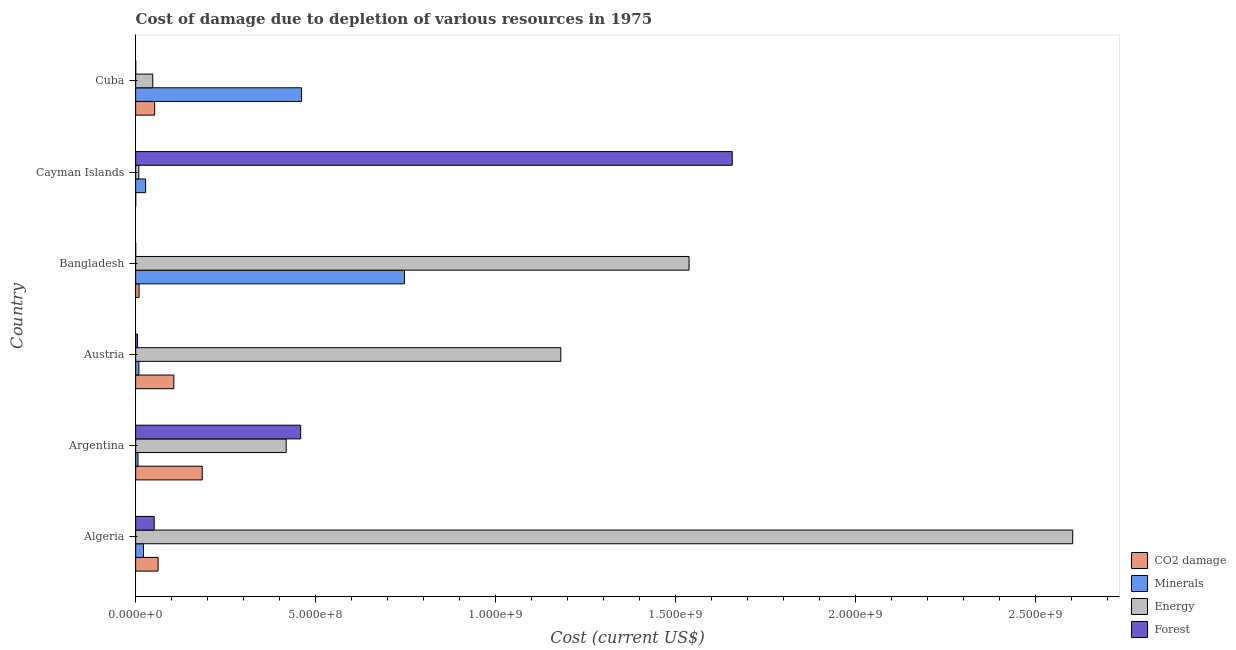How many different coloured bars are there?
Your answer should be very brief. 4. How many bars are there on the 5th tick from the top?
Provide a short and direct response. 4. What is the cost of damage due to depletion of forests in Argentina?
Your answer should be very brief. 4.58e+08. Across all countries, what is the maximum cost of damage due to depletion of energy?
Your answer should be compact. 2.60e+09. Across all countries, what is the minimum cost of damage due to depletion of forests?
Ensure brevity in your answer.  8.47e+04. What is the total cost of damage due to depletion of energy in the graph?
Make the answer very short. 5.80e+09. What is the difference between the cost of damage due to depletion of forests in Argentina and that in Austria?
Keep it short and to the point. 4.53e+08. What is the difference between the cost of damage due to depletion of coal in Austria and the cost of damage due to depletion of forests in Algeria?
Your response must be concise. 5.45e+07. What is the average cost of damage due to depletion of energy per country?
Provide a short and direct response. 9.66e+08. What is the difference between the cost of damage due to depletion of minerals and cost of damage due to depletion of forests in Cuba?
Offer a very short reply. 4.61e+08. In how many countries, is the cost of damage due to depletion of coal greater than 1400000000 US$?
Make the answer very short. 0. What is the ratio of the cost of damage due to depletion of minerals in Argentina to that in Austria?
Ensure brevity in your answer.  0.72. Is the cost of damage due to depletion of coal in Algeria less than that in Cayman Islands?
Your answer should be very brief. No. Is the difference between the cost of damage due to depletion of minerals in Algeria and Cuba greater than the difference between the cost of damage due to depletion of forests in Algeria and Cuba?
Make the answer very short. No. What is the difference between the highest and the second highest cost of damage due to depletion of forests?
Your answer should be very brief. 1.20e+09. What is the difference between the highest and the lowest cost of damage due to depletion of minerals?
Keep it short and to the point. 7.40e+08. In how many countries, is the cost of damage due to depletion of minerals greater than the average cost of damage due to depletion of minerals taken over all countries?
Keep it short and to the point. 2. Is it the case that in every country, the sum of the cost of damage due to depletion of energy and cost of damage due to depletion of minerals is greater than the sum of cost of damage due to depletion of coal and cost of damage due to depletion of forests?
Offer a very short reply. No. What does the 2nd bar from the top in Algeria represents?
Provide a succinct answer. Energy. What does the 2nd bar from the bottom in Cayman Islands represents?
Offer a very short reply. Minerals. Is it the case that in every country, the sum of the cost of damage due to depletion of coal and cost of damage due to depletion of minerals is greater than the cost of damage due to depletion of energy?
Offer a very short reply. No. What is the difference between two consecutive major ticks on the X-axis?
Provide a short and direct response. 5.00e+08. Does the graph contain any zero values?
Offer a very short reply. No. Does the graph contain grids?
Provide a short and direct response. No. How many legend labels are there?
Give a very brief answer. 4. What is the title of the graph?
Offer a very short reply. Cost of damage due to depletion of various resources in 1975 . What is the label or title of the X-axis?
Offer a very short reply. Cost (current US$). What is the label or title of the Y-axis?
Make the answer very short. Country. What is the Cost (current US$) in CO2 damage in Algeria?
Ensure brevity in your answer.  6.24e+07. What is the Cost (current US$) of Minerals in Algeria?
Offer a very short reply. 2.17e+07. What is the Cost (current US$) of Energy in Algeria?
Give a very brief answer. 2.60e+09. What is the Cost (current US$) in Forest in Algeria?
Offer a very short reply. 5.14e+07. What is the Cost (current US$) of CO2 damage in Argentina?
Keep it short and to the point. 1.85e+08. What is the Cost (current US$) of Minerals in Argentina?
Your answer should be compact. 6.41e+06. What is the Cost (current US$) in Energy in Argentina?
Offer a very short reply. 4.18e+08. What is the Cost (current US$) of Forest in Argentina?
Provide a short and direct response. 4.58e+08. What is the Cost (current US$) of CO2 damage in Austria?
Keep it short and to the point. 1.06e+08. What is the Cost (current US$) of Minerals in Austria?
Ensure brevity in your answer.  8.94e+06. What is the Cost (current US$) in Energy in Austria?
Provide a short and direct response. 1.18e+09. What is the Cost (current US$) in Forest in Austria?
Your answer should be very brief. 5.10e+06. What is the Cost (current US$) of CO2 damage in Bangladesh?
Give a very brief answer. 9.49e+06. What is the Cost (current US$) in Minerals in Bangladesh?
Provide a succinct answer. 7.47e+08. What is the Cost (current US$) in Energy in Bangladesh?
Ensure brevity in your answer.  1.54e+09. What is the Cost (current US$) of Forest in Bangladesh?
Provide a succinct answer. 8.47e+04. What is the Cost (current US$) of CO2 damage in Cayman Islands?
Ensure brevity in your answer.  1.14e+05. What is the Cost (current US$) of Minerals in Cayman Islands?
Ensure brevity in your answer.  2.76e+07. What is the Cost (current US$) in Energy in Cayman Islands?
Make the answer very short. 8.74e+06. What is the Cost (current US$) in Forest in Cayman Islands?
Your answer should be very brief. 1.66e+09. What is the Cost (current US$) of CO2 damage in Cuba?
Your answer should be compact. 5.27e+07. What is the Cost (current US$) of Minerals in Cuba?
Your answer should be compact. 4.61e+08. What is the Cost (current US$) in Energy in Cuba?
Your answer should be compact. 4.74e+07. What is the Cost (current US$) in Forest in Cuba?
Give a very brief answer. 1.50e+05. Across all countries, what is the maximum Cost (current US$) of CO2 damage?
Offer a terse response. 1.85e+08. Across all countries, what is the maximum Cost (current US$) of Minerals?
Provide a succinct answer. 7.47e+08. Across all countries, what is the maximum Cost (current US$) in Energy?
Offer a very short reply. 2.60e+09. Across all countries, what is the maximum Cost (current US$) of Forest?
Make the answer very short. 1.66e+09. Across all countries, what is the minimum Cost (current US$) of CO2 damage?
Provide a short and direct response. 1.14e+05. Across all countries, what is the minimum Cost (current US$) in Minerals?
Provide a short and direct response. 6.41e+06. Across all countries, what is the minimum Cost (current US$) in Energy?
Offer a very short reply. 8.74e+06. Across all countries, what is the minimum Cost (current US$) of Forest?
Provide a succinct answer. 8.47e+04. What is the total Cost (current US$) in CO2 damage in the graph?
Your answer should be compact. 4.16e+08. What is the total Cost (current US$) in Minerals in the graph?
Provide a succinct answer. 1.27e+09. What is the total Cost (current US$) in Energy in the graph?
Offer a very short reply. 5.80e+09. What is the total Cost (current US$) of Forest in the graph?
Give a very brief answer. 2.17e+09. What is the difference between the Cost (current US$) in CO2 damage in Algeria and that in Argentina?
Give a very brief answer. -1.23e+08. What is the difference between the Cost (current US$) in Minerals in Algeria and that in Argentina?
Ensure brevity in your answer.  1.53e+07. What is the difference between the Cost (current US$) of Energy in Algeria and that in Argentina?
Make the answer very short. 2.18e+09. What is the difference between the Cost (current US$) in Forest in Algeria and that in Argentina?
Offer a terse response. -4.07e+08. What is the difference between the Cost (current US$) of CO2 damage in Algeria and that in Austria?
Offer a terse response. -4.36e+07. What is the difference between the Cost (current US$) in Minerals in Algeria and that in Austria?
Offer a very short reply. 1.27e+07. What is the difference between the Cost (current US$) of Energy in Algeria and that in Austria?
Provide a succinct answer. 1.42e+09. What is the difference between the Cost (current US$) of Forest in Algeria and that in Austria?
Provide a short and direct response. 4.63e+07. What is the difference between the Cost (current US$) in CO2 damage in Algeria and that in Bangladesh?
Offer a very short reply. 5.29e+07. What is the difference between the Cost (current US$) of Minerals in Algeria and that in Bangladesh?
Make the answer very short. -7.25e+08. What is the difference between the Cost (current US$) in Energy in Algeria and that in Bangladesh?
Provide a short and direct response. 1.07e+09. What is the difference between the Cost (current US$) in Forest in Algeria and that in Bangladesh?
Your answer should be very brief. 5.13e+07. What is the difference between the Cost (current US$) of CO2 damage in Algeria and that in Cayman Islands?
Keep it short and to the point. 6.23e+07. What is the difference between the Cost (current US$) of Minerals in Algeria and that in Cayman Islands?
Your answer should be compact. -5.88e+06. What is the difference between the Cost (current US$) of Energy in Algeria and that in Cayman Islands?
Your response must be concise. 2.59e+09. What is the difference between the Cost (current US$) in Forest in Algeria and that in Cayman Islands?
Make the answer very short. -1.61e+09. What is the difference between the Cost (current US$) of CO2 damage in Algeria and that in Cuba?
Offer a terse response. 9.67e+06. What is the difference between the Cost (current US$) of Minerals in Algeria and that in Cuba?
Provide a short and direct response. -4.39e+08. What is the difference between the Cost (current US$) of Energy in Algeria and that in Cuba?
Your answer should be very brief. 2.56e+09. What is the difference between the Cost (current US$) of Forest in Algeria and that in Cuba?
Offer a very short reply. 5.13e+07. What is the difference between the Cost (current US$) in CO2 damage in Argentina and that in Austria?
Offer a very short reply. 7.90e+07. What is the difference between the Cost (current US$) in Minerals in Argentina and that in Austria?
Your response must be concise. -2.52e+06. What is the difference between the Cost (current US$) of Energy in Argentina and that in Austria?
Make the answer very short. -7.63e+08. What is the difference between the Cost (current US$) in Forest in Argentina and that in Austria?
Give a very brief answer. 4.53e+08. What is the difference between the Cost (current US$) of CO2 damage in Argentina and that in Bangladesh?
Offer a very short reply. 1.75e+08. What is the difference between the Cost (current US$) of Minerals in Argentina and that in Bangladesh?
Offer a terse response. -7.40e+08. What is the difference between the Cost (current US$) of Energy in Argentina and that in Bangladesh?
Ensure brevity in your answer.  -1.12e+09. What is the difference between the Cost (current US$) of Forest in Argentina and that in Bangladesh?
Offer a terse response. 4.58e+08. What is the difference between the Cost (current US$) in CO2 damage in Argentina and that in Cayman Islands?
Give a very brief answer. 1.85e+08. What is the difference between the Cost (current US$) in Minerals in Argentina and that in Cayman Islands?
Offer a terse response. -2.12e+07. What is the difference between the Cost (current US$) in Energy in Argentina and that in Cayman Islands?
Provide a succinct answer. 4.09e+08. What is the difference between the Cost (current US$) in Forest in Argentina and that in Cayman Islands?
Keep it short and to the point. -1.20e+09. What is the difference between the Cost (current US$) of CO2 damage in Argentina and that in Cuba?
Your response must be concise. 1.32e+08. What is the difference between the Cost (current US$) of Minerals in Argentina and that in Cuba?
Keep it short and to the point. -4.54e+08. What is the difference between the Cost (current US$) in Energy in Argentina and that in Cuba?
Your response must be concise. 3.71e+08. What is the difference between the Cost (current US$) of Forest in Argentina and that in Cuba?
Provide a short and direct response. 4.58e+08. What is the difference between the Cost (current US$) in CO2 damage in Austria and that in Bangladesh?
Offer a terse response. 9.65e+07. What is the difference between the Cost (current US$) in Minerals in Austria and that in Bangladesh?
Provide a succinct answer. -7.38e+08. What is the difference between the Cost (current US$) of Energy in Austria and that in Bangladesh?
Your answer should be very brief. -3.56e+08. What is the difference between the Cost (current US$) in Forest in Austria and that in Bangladesh?
Provide a succinct answer. 5.01e+06. What is the difference between the Cost (current US$) of CO2 damage in Austria and that in Cayman Islands?
Your answer should be very brief. 1.06e+08. What is the difference between the Cost (current US$) in Minerals in Austria and that in Cayman Islands?
Provide a short and direct response. -1.86e+07. What is the difference between the Cost (current US$) in Energy in Austria and that in Cayman Islands?
Make the answer very short. 1.17e+09. What is the difference between the Cost (current US$) of Forest in Austria and that in Cayman Islands?
Your answer should be compact. -1.65e+09. What is the difference between the Cost (current US$) of CO2 damage in Austria and that in Cuba?
Your answer should be very brief. 5.32e+07. What is the difference between the Cost (current US$) in Minerals in Austria and that in Cuba?
Offer a very short reply. -4.52e+08. What is the difference between the Cost (current US$) of Energy in Austria and that in Cuba?
Offer a terse response. 1.13e+09. What is the difference between the Cost (current US$) in Forest in Austria and that in Cuba?
Your answer should be compact. 4.95e+06. What is the difference between the Cost (current US$) of CO2 damage in Bangladesh and that in Cayman Islands?
Give a very brief answer. 9.37e+06. What is the difference between the Cost (current US$) of Minerals in Bangladesh and that in Cayman Islands?
Provide a succinct answer. 7.19e+08. What is the difference between the Cost (current US$) in Energy in Bangladesh and that in Cayman Islands?
Provide a succinct answer. 1.53e+09. What is the difference between the Cost (current US$) in Forest in Bangladesh and that in Cayman Islands?
Your answer should be compact. -1.66e+09. What is the difference between the Cost (current US$) of CO2 damage in Bangladesh and that in Cuba?
Provide a succinct answer. -4.32e+07. What is the difference between the Cost (current US$) of Minerals in Bangladesh and that in Cuba?
Offer a terse response. 2.86e+08. What is the difference between the Cost (current US$) in Energy in Bangladesh and that in Cuba?
Make the answer very short. 1.49e+09. What is the difference between the Cost (current US$) in Forest in Bangladesh and that in Cuba?
Keep it short and to the point. -6.53e+04. What is the difference between the Cost (current US$) in CO2 damage in Cayman Islands and that in Cuba?
Ensure brevity in your answer.  -5.26e+07. What is the difference between the Cost (current US$) in Minerals in Cayman Islands and that in Cuba?
Your response must be concise. -4.33e+08. What is the difference between the Cost (current US$) in Energy in Cayman Islands and that in Cuba?
Provide a succinct answer. -3.87e+07. What is the difference between the Cost (current US$) in Forest in Cayman Islands and that in Cuba?
Your answer should be very brief. 1.66e+09. What is the difference between the Cost (current US$) of CO2 damage in Algeria and the Cost (current US$) of Minerals in Argentina?
Your answer should be compact. 5.60e+07. What is the difference between the Cost (current US$) in CO2 damage in Algeria and the Cost (current US$) in Energy in Argentina?
Your answer should be compact. -3.56e+08. What is the difference between the Cost (current US$) of CO2 damage in Algeria and the Cost (current US$) of Forest in Argentina?
Offer a very short reply. -3.96e+08. What is the difference between the Cost (current US$) in Minerals in Algeria and the Cost (current US$) in Energy in Argentina?
Provide a short and direct response. -3.97e+08. What is the difference between the Cost (current US$) of Minerals in Algeria and the Cost (current US$) of Forest in Argentina?
Ensure brevity in your answer.  -4.37e+08. What is the difference between the Cost (current US$) in Energy in Algeria and the Cost (current US$) in Forest in Argentina?
Provide a succinct answer. 2.14e+09. What is the difference between the Cost (current US$) of CO2 damage in Algeria and the Cost (current US$) of Minerals in Austria?
Offer a terse response. 5.35e+07. What is the difference between the Cost (current US$) of CO2 damage in Algeria and the Cost (current US$) of Energy in Austria?
Your answer should be compact. -1.12e+09. What is the difference between the Cost (current US$) in CO2 damage in Algeria and the Cost (current US$) in Forest in Austria?
Offer a terse response. 5.73e+07. What is the difference between the Cost (current US$) of Minerals in Algeria and the Cost (current US$) of Energy in Austria?
Provide a succinct answer. -1.16e+09. What is the difference between the Cost (current US$) in Minerals in Algeria and the Cost (current US$) in Forest in Austria?
Your answer should be compact. 1.66e+07. What is the difference between the Cost (current US$) of Energy in Algeria and the Cost (current US$) of Forest in Austria?
Provide a short and direct response. 2.60e+09. What is the difference between the Cost (current US$) in CO2 damage in Algeria and the Cost (current US$) in Minerals in Bangladesh?
Your response must be concise. -6.84e+08. What is the difference between the Cost (current US$) in CO2 damage in Algeria and the Cost (current US$) in Energy in Bangladesh?
Offer a very short reply. -1.47e+09. What is the difference between the Cost (current US$) in CO2 damage in Algeria and the Cost (current US$) in Forest in Bangladesh?
Offer a terse response. 6.23e+07. What is the difference between the Cost (current US$) in Minerals in Algeria and the Cost (current US$) in Energy in Bangladesh?
Ensure brevity in your answer.  -1.52e+09. What is the difference between the Cost (current US$) of Minerals in Algeria and the Cost (current US$) of Forest in Bangladesh?
Give a very brief answer. 2.16e+07. What is the difference between the Cost (current US$) in Energy in Algeria and the Cost (current US$) in Forest in Bangladesh?
Your response must be concise. 2.60e+09. What is the difference between the Cost (current US$) of CO2 damage in Algeria and the Cost (current US$) of Minerals in Cayman Islands?
Provide a succinct answer. 3.48e+07. What is the difference between the Cost (current US$) in CO2 damage in Algeria and the Cost (current US$) in Energy in Cayman Islands?
Offer a very short reply. 5.37e+07. What is the difference between the Cost (current US$) of CO2 damage in Algeria and the Cost (current US$) of Forest in Cayman Islands?
Your response must be concise. -1.59e+09. What is the difference between the Cost (current US$) of Minerals in Algeria and the Cost (current US$) of Energy in Cayman Islands?
Make the answer very short. 1.29e+07. What is the difference between the Cost (current US$) of Minerals in Algeria and the Cost (current US$) of Forest in Cayman Islands?
Your answer should be compact. -1.64e+09. What is the difference between the Cost (current US$) in Energy in Algeria and the Cost (current US$) in Forest in Cayman Islands?
Provide a succinct answer. 9.46e+08. What is the difference between the Cost (current US$) of CO2 damage in Algeria and the Cost (current US$) of Minerals in Cuba?
Ensure brevity in your answer.  -3.98e+08. What is the difference between the Cost (current US$) of CO2 damage in Algeria and the Cost (current US$) of Energy in Cuba?
Your answer should be compact. 1.50e+07. What is the difference between the Cost (current US$) in CO2 damage in Algeria and the Cost (current US$) in Forest in Cuba?
Ensure brevity in your answer.  6.22e+07. What is the difference between the Cost (current US$) of Minerals in Algeria and the Cost (current US$) of Energy in Cuba?
Your response must be concise. -2.58e+07. What is the difference between the Cost (current US$) of Minerals in Algeria and the Cost (current US$) of Forest in Cuba?
Make the answer very short. 2.15e+07. What is the difference between the Cost (current US$) of Energy in Algeria and the Cost (current US$) of Forest in Cuba?
Give a very brief answer. 2.60e+09. What is the difference between the Cost (current US$) in CO2 damage in Argentina and the Cost (current US$) in Minerals in Austria?
Give a very brief answer. 1.76e+08. What is the difference between the Cost (current US$) of CO2 damage in Argentina and the Cost (current US$) of Energy in Austria?
Ensure brevity in your answer.  -9.96e+08. What is the difference between the Cost (current US$) in CO2 damage in Argentina and the Cost (current US$) in Forest in Austria?
Ensure brevity in your answer.  1.80e+08. What is the difference between the Cost (current US$) of Minerals in Argentina and the Cost (current US$) of Energy in Austria?
Your answer should be very brief. -1.17e+09. What is the difference between the Cost (current US$) in Minerals in Argentina and the Cost (current US$) in Forest in Austria?
Your response must be concise. 1.32e+06. What is the difference between the Cost (current US$) in Energy in Argentina and the Cost (current US$) in Forest in Austria?
Provide a succinct answer. 4.13e+08. What is the difference between the Cost (current US$) of CO2 damage in Argentina and the Cost (current US$) of Minerals in Bangladesh?
Ensure brevity in your answer.  -5.62e+08. What is the difference between the Cost (current US$) of CO2 damage in Argentina and the Cost (current US$) of Energy in Bangladesh?
Keep it short and to the point. -1.35e+09. What is the difference between the Cost (current US$) in CO2 damage in Argentina and the Cost (current US$) in Forest in Bangladesh?
Provide a short and direct response. 1.85e+08. What is the difference between the Cost (current US$) of Minerals in Argentina and the Cost (current US$) of Energy in Bangladesh?
Offer a terse response. -1.53e+09. What is the difference between the Cost (current US$) in Minerals in Argentina and the Cost (current US$) in Forest in Bangladesh?
Your response must be concise. 6.33e+06. What is the difference between the Cost (current US$) in Energy in Argentina and the Cost (current US$) in Forest in Bangladesh?
Ensure brevity in your answer.  4.18e+08. What is the difference between the Cost (current US$) of CO2 damage in Argentina and the Cost (current US$) of Minerals in Cayman Islands?
Your answer should be very brief. 1.57e+08. What is the difference between the Cost (current US$) in CO2 damage in Argentina and the Cost (current US$) in Energy in Cayman Islands?
Your response must be concise. 1.76e+08. What is the difference between the Cost (current US$) of CO2 damage in Argentina and the Cost (current US$) of Forest in Cayman Islands?
Keep it short and to the point. -1.47e+09. What is the difference between the Cost (current US$) in Minerals in Argentina and the Cost (current US$) in Energy in Cayman Islands?
Your answer should be compact. -2.32e+06. What is the difference between the Cost (current US$) of Minerals in Argentina and the Cost (current US$) of Forest in Cayman Islands?
Make the answer very short. -1.65e+09. What is the difference between the Cost (current US$) in Energy in Argentina and the Cost (current US$) in Forest in Cayman Islands?
Make the answer very short. -1.24e+09. What is the difference between the Cost (current US$) of CO2 damage in Argentina and the Cost (current US$) of Minerals in Cuba?
Keep it short and to the point. -2.76e+08. What is the difference between the Cost (current US$) of CO2 damage in Argentina and the Cost (current US$) of Energy in Cuba?
Offer a very short reply. 1.37e+08. What is the difference between the Cost (current US$) in CO2 damage in Argentina and the Cost (current US$) in Forest in Cuba?
Provide a short and direct response. 1.85e+08. What is the difference between the Cost (current US$) of Minerals in Argentina and the Cost (current US$) of Energy in Cuba?
Ensure brevity in your answer.  -4.10e+07. What is the difference between the Cost (current US$) in Minerals in Argentina and the Cost (current US$) in Forest in Cuba?
Provide a short and direct response. 6.26e+06. What is the difference between the Cost (current US$) in Energy in Argentina and the Cost (current US$) in Forest in Cuba?
Your response must be concise. 4.18e+08. What is the difference between the Cost (current US$) in CO2 damage in Austria and the Cost (current US$) in Minerals in Bangladesh?
Your answer should be very brief. -6.41e+08. What is the difference between the Cost (current US$) in CO2 damage in Austria and the Cost (current US$) in Energy in Bangladesh?
Give a very brief answer. -1.43e+09. What is the difference between the Cost (current US$) of CO2 damage in Austria and the Cost (current US$) of Forest in Bangladesh?
Your answer should be compact. 1.06e+08. What is the difference between the Cost (current US$) in Minerals in Austria and the Cost (current US$) in Energy in Bangladesh?
Offer a very short reply. -1.53e+09. What is the difference between the Cost (current US$) of Minerals in Austria and the Cost (current US$) of Forest in Bangladesh?
Provide a short and direct response. 8.85e+06. What is the difference between the Cost (current US$) of Energy in Austria and the Cost (current US$) of Forest in Bangladesh?
Offer a terse response. 1.18e+09. What is the difference between the Cost (current US$) of CO2 damage in Austria and the Cost (current US$) of Minerals in Cayman Islands?
Ensure brevity in your answer.  7.84e+07. What is the difference between the Cost (current US$) in CO2 damage in Austria and the Cost (current US$) in Energy in Cayman Islands?
Provide a short and direct response. 9.72e+07. What is the difference between the Cost (current US$) in CO2 damage in Austria and the Cost (current US$) in Forest in Cayman Islands?
Give a very brief answer. -1.55e+09. What is the difference between the Cost (current US$) of Minerals in Austria and the Cost (current US$) of Energy in Cayman Islands?
Make the answer very short. 1.98e+05. What is the difference between the Cost (current US$) in Minerals in Austria and the Cost (current US$) in Forest in Cayman Islands?
Give a very brief answer. -1.65e+09. What is the difference between the Cost (current US$) in Energy in Austria and the Cost (current US$) in Forest in Cayman Islands?
Offer a terse response. -4.76e+08. What is the difference between the Cost (current US$) in CO2 damage in Austria and the Cost (current US$) in Minerals in Cuba?
Keep it short and to the point. -3.55e+08. What is the difference between the Cost (current US$) in CO2 damage in Austria and the Cost (current US$) in Energy in Cuba?
Provide a short and direct response. 5.85e+07. What is the difference between the Cost (current US$) in CO2 damage in Austria and the Cost (current US$) in Forest in Cuba?
Provide a short and direct response. 1.06e+08. What is the difference between the Cost (current US$) of Minerals in Austria and the Cost (current US$) of Energy in Cuba?
Make the answer very short. -3.85e+07. What is the difference between the Cost (current US$) in Minerals in Austria and the Cost (current US$) in Forest in Cuba?
Ensure brevity in your answer.  8.79e+06. What is the difference between the Cost (current US$) of Energy in Austria and the Cost (current US$) of Forest in Cuba?
Your answer should be compact. 1.18e+09. What is the difference between the Cost (current US$) in CO2 damage in Bangladesh and the Cost (current US$) in Minerals in Cayman Islands?
Ensure brevity in your answer.  -1.81e+07. What is the difference between the Cost (current US$) of CO2 damage in Bangladesh and the Cost (current US$) of Energy in Cayman Islands?
Offer a terse response. 7.48e+05. What is the difference between the Cost (current US$) in CO2 damage in Bangladesh and the Cost (current US$) in Forest in Cayman Islands?
Your answer should be compact. -1.65e+09. What is the difference between the Cost (current US$) of Minerals in Bangladesh and the Cost (current US$) of Energy in Cayman Islands?
Provide a short and direct response. 7.38e+08. What is the difference between the Cost (current US$) of Minerals in Bangladesh and the Cost (current US$) of Forest in Cayman Islands?
Keep it short and to the point. -9.11e+08. What is the difference between the Cost (current US$) of Energy in Bangladesh and the Cost (current US$) of Forest in Cayman Islands?
Make the answer very short. -1.20e+08. What is the difference between the Cost (current US$) in CO2 damage in Bangladesh and the Cost (current US$) in Minerals in Cuba?
Your answer should be very brief. -4.51e+08. What is the difference between the Cost (current US$) of CO2 damage in Bangladesh and the Cost (current US$) of Energy in Cuba?
Your answer should be very brief. -3.80e+07. What is the difference between the Cost (current US$) of CO2 damage in Bangladesh and the Cost (current US$) of Forest in Cuba?
Provide a succinct answer. 9.34e+06. What is the difference between the Cost (current US$) of Minerals in Bangladesh and the Cost (current US$) of Energy in Cuba?
Provide a short and direct response. 6.99e+08. What is the difference between the Cost (current US$) of Minerals in Bangladesh and the Cost (current US$) of Forest in Cuba?
Offer a very short reply. 7.46e+08. What is the difference between the Cost (current US$) in Energy in Bangladesh and the Cost (current US$) in Forest in Cuba?
Ensure brevity in your answer.  1.54e+09. What is the difference between the Cost (current US$) of CO2 damage in Cayman Islands and the Cost (current US$) of Minerals in Cuba?
Your answer should be very brief. -4.61e+08. What is the difference between the Cost (current US$) of CO2 damage in Cayman Islands and the Cost (current US$) of Energy in Cuba?
Your response must be concise. -4.73e+07. What is the difference between the Cost (current US$) of CO2 damage in Cayman Islands and the Cost (current US$) of Forest in Cuba?
Your answer should be compact. -3.58e+04. What is the difference between the Cost (current US$) in Minerals in Cayman Islands and the Cost (current US$) in Energy in Cuba?
Ensure brevity in your answer.  -1.99e+07. What is the difference between the Cost (current US$) in Minerals in Cayman Islands and the Cost (current US$) in Forest in Cuba?
Your answer should be very brief. 2.74e+07. What is the difference between the Cost (current US$) of Energy in Cayman Islands and the Cost (current US$) of Forest in Cuba?
Offer a terse response. 8.59e+06. What is the average Cost (current US$) in CO2 damage per country?
Provide a succinct answer. 6.93e+07. What is the average Cost (current US$) in Minerals per country?
Your answer should be compact. 2.12e+08. What is the average Cost (current US$) of Energy per country?
Your answer should be very brief. 9.66e+08. What is the average Cost (current US$) in Forest per country?
Ensure brevity in your answer.  3.62e+08. What is the difference between the Cost (current US$) in CO2 damage and Cost (current US$) in Minerals in Algeria?
Your answer should be very brief. 4.07e+07. What is the difference between the Cost (current US$) in CO2 damage and Cost (current US$) in Energy in Algeria?
Your response must be concise. -2.54e+09. What is the difference between the Cost (current US$) of CO2 damage and Cost (current US$) of Forest in Algeria?
Your answer should be compact. 1.10e+07. What is the difference between the Cost (current US$) of Minerals and Cost (current US$) of Energy in Algeria?
Provide a succinct answer. -2.58e+09. What is the difference between the Cost (current US$) of Minerals and Cost (current US$) of Forest in Algeria?
Your answer should be compact. -2.97e+07. What is the difference between the Cost (current US$) of Energy and Cost (current US$) of Forest in Algeria?
Keep it short and to the point. 2.55e+09. What is the difference between the Cost (current US$) in CO2 damage and Cost (current US$) in Minerals in Argentina?
Keep it short and to the point. 1.78e+08. What is the difference between the Cost (current US$) of CO2 damage and Cost (current US$) of Energy in Argentina?
Keep it short and to the point. -2.33e+08. What is the difference between the Cost (current US$) of CO2 damage and Cost (current US$) of Forest in Argentina?
Offer a terse response. -2.73e+08. What is the difference between the Cost (current US$) in Minerals and Cost (current US$) in Energy in Argentina?
Your response must be concise. -4.12e+08. What is the difference between the Cost (current US$) of Minerals and Cost (current US$) of Forest in Argentina?
Offer a very short reply. -4.52e+08. What is the difference between the Cost (current US$) in Energy and Cost (current US$) in Forest in Argentina?
Give a very brief answer. -4.01e+07. What is the difference between the Cost (current US$) of CO2 damage and Cost (current US$) of Minerals in Austria?
Your response must be concise. 9.70e+07. What is the difference between the Cost (current US$) of CO2 damage and Cost (current US$) of Energy in Austria?
Ensure brevity in your answer.  -1.08e+09. What is the difference between the Cost (current US$) of CO2 damage and Cost (current US$) of Forest in Austria?
Give a very brief answer. 1.01e+08. What is the difference between the Cost (current US$) of Minerals and Cost (current US$) of Energy in Austria?
Ensure brevity in your answer.  -1.17e+09. What is the difference between the Cost (current US$) in Minerals and Cost (current US$) in Forest in Austria?
Keep it short and to the point. 3.84e+06. What is the difference between the Cost (current US$) in Energy and Cost (current US$) in Forest in Austria?
Ensure brevity in your answer.  1.18e+09. What is the difference between the Cost (current US$) of CO2 damage and Cost (current US$) of Minerals in Bangladesh?
Provide a short and direct response. -7.37e+08. What is the difference between the Cost (current US$) in CO2 damage and Cost (current US$) in Energy in Bangladesh?
Your answer should be very brief. -1.53e+09. What is the difference between the Cost (current US$) of CO2 damage and Cost (current US$) of Forest in Bangladesh?
Your answer should be very brief. 9.40e+06. What is the difference between the Cost (current US$) in Minerals and Cost (current US$) in Energy in Bangladesh?
Make the answer very short. -7.91e+08. What is the difference between the Cost (current US$) in Minerals and Cost (current US$) in Forest in Bangladesh?
Provide a short and direct response. 7.47e+08. What is the difference between the Cost (current US$) in Energy and Cost (current US$) in Forest in Bangladesh?
Give a very brief answer. 1.54e+09. What is the difference between the Cost (current US$) of CO2 damage and Cost (current US$) of Minerals in Cayman Islands?
Provide a succinct answer. -2.75e+07. What is the difference between the Cost (current US$) in CO2 damage and Cost (current US$) in Energy in Cayman Islands?
Provide a short and direct response. -8.62e+06. What is the difference between the Cost (current US$) in CO2 damage and Cost (current US$) in Forest in Cayman Islands?
Provide a succinct answer. -1.66e+09. What is the difference between the Cost (current US$) of Minerals and Cost (current US$) of Energy in Cayman Islands?
Make the answer very short. 1.88e+07. What is the difference between the Cost (current US$) in Minerals and Cost (current US$) in Forest in Cayman Islands?
Make the answer very short. -1.63e+09. What is the difference between the Cost (current US$) of Energy and Cost (current US$) of Forest in Cayman Islands?
Your answer should be very brief. -1.65e+09. What is the difference between the Cost (current US$) in CO2 damage and Cost (current US$) in Minerals in Cuba?
Keep it short and to the point. -4.08e+08. What is the difference between the Cost (current US$) of CO2 damage and Cost (current US$) of Energy in Cuba?
Give a very brief answer. 5.28e+06. What is the difference between the Cost (current US$) in CO2 damage and Cost (current US$) in Forest in Cuba?
Ensure brevity in your answer.  5.26e+07. What is the difference between the Cost (current US$) of Minerals and Cost (current US$) of Energy in Cuba?
Keep it short and to the point. 4.13e+08. What is the difference between the Cost (current US$) of Minerals and Cost (current US$) of Forest in Cuba?
Your answer should be very brief. 4.61e+08. What is the difference between the Cost (current US$) of Energy and Cost (current US$) of Forest in Cuba?
Provide a succinct answer. 4.73e+07. What is the ratio of the Cost (current US$) of CO2 damage in Algeria to that in Argentina?
Offer a terse response. 0.34. What is the ratio of the Cost (current US$) of Minerals in Algeria to that in Argentina?
Give a very brief answer. 3.38. What is the ratio of the Cost (current US$) of Energy in Algeria to that in Argentina?
Your response must be concise. 6.22. What is the ratio of the Cost (current US$) of Forest in Algeria to that in Argentina?
Keep it short and to the point. 0.11. What is the ratio of the Cost (current US$) of CO2 damage in Algeria to that in Austria?
Your answer should be compact. 0.59. What is the ratio of the Cost (current US$) of Minerals in Algeria to that in Austria?
Your answer should be compact. 2.43. What is the ratio of the Cost (current US$) of Energy in Algeria to that in Austria?
Your response must be concise. 2.2. What is the ratio of the Cost (current US$) in Forest in Algeria to that in Austria?
Offer a terse response. 10.09. What is the ratio of the Cost (current US$) in CO2 damage in Algeria to that in Bangladesh?
Ensure brevity in your answer.  6.58. What is the ratio of the Cost (current US$) in Minerals in Algeria to that in Bangladesh?
Your answer should be very brief. 0.03. What is the ratio of the Cost (current US$) in Energy in Algeria to that in Bangladesh?
Your response must be concise. 1.69. What is the ratio of the Cost (current US$) in Forest in Algeria to that in Bangladesh?
Your answer should be very brief. 606.81. What is the ratio of the Cost (current US$) in CO2 damage in Algeria to that in Cayman Islands?
Make the answer very short. 545.94. What is the ratio of the Cost (current US$) of Minerals in Algeria to that in Cayman Islands?
Offer a very short reply. 0.79. What is the ratio of the Cost (current US$) of Energy in Algeria to that in Cayman Islands?
Your answer should be compact. 297.91. What is the ratio of the Cost (current US$) in Forest in Algeria to that in Cayman Islands?
Keep it short and to the point. 0.03. What is the ratio of the Cost (current US$) in CO2 damage in Algeria to that in Cuba?
Your answer should be compact. 1.18. What is the ratio of the Cost (current US$) of Minerals in Algeria to that in Cuba?
Offer a very short reply. 0.05. What is the ratio of the Cost (current US$) of Energy in Algeria to that in Cuba?
Offer a very short reply. 54.87. What is the ratio of the Cost (current US$) of Forest in Algeria to that in Cuba?
Provide a short and direct response. 342.76. What is the ratio of the Cost (current US$) of CO2 damage in Argentina to that in Austria?
Your response must be concise. 1.75. What is the ratio of the Cost (current US$) of Minerals in Argentina to that in Austria?
Keep it short and to the point. 0.72. What is the ratio of the Cost (current US$) of Energy in Argentina to that in Austria?
Your answer should be compact. 0.35. What is the ratio of the Cost (current US$) in Forest in Argentina to that in Austria?
Make the answer very short. 89.93. What is the ratio of the Cost (current US$) of CO2 damage in Argentina to that in Bangladesh?
Ensure brevity in your answer.  19.49. What is the ratio of the Cost (current US$) in Minerals in Argentina to that in Bangladesh?
Make the answer very short. 0.01. What is the ratio of the Cost (current US$) of Energy in Argentina to that in Bangladesh?
Provide a succinct answer. 0.27. What is the ratio of the Cost (current US$) of Forest in Argentina to that in Bangladesh?
Make the answer very short. 5408.04. What is the ratio of the Cost (current US$) of CO2 damage in Argentina to that in Cayman Islands?
Your answer should be compact. 1618. What is the ratio of the Cost (current US$) of Minerals in Argentina to that in Cayman Islands?
Offer a very short reply. 0.23. What is the ratio of the Cost (current US$) in Energy in Argentina to that in Cayman Islands?
Offer a terse response. 47.86. What is the ratio of the Cost (current US$) in Forest in Argentina to that in Cayman Islands?
Give a very brief answer. 0.28. What is the ratio of the Cost (current US$) in CO2 damage in Argentina to that in Cuba?
Your answer should be compact. 3.51. What is the ratio of the Cost (current US$) of Minerals in Argentina to that in Cuba?
Your answer should be very brief. 0.01. What is the ratio of the Cost (current US$) of Energy in Argentina to that in Cuba?
Offer a very short reply. 8.82. What is the ratio of the Cost (current US$) in Forest in Argentina to that in Cuba?
Your answer should be very brief. 3054.75. What is the ratio of the Cost (current US$) of CO2 damage in Austria to that in Bangladesh?
Offer a terse response. 11.17. What is the ratio of the Cost (current US$) in Minerals in Austria to that in Bangladesh?
Offer a very short reply. 0.01. What is the ratio of the Cost (current US$) of Energy in Austria to that in Bangladesh?
Keep it short and to the point. 0.77. What is the ratio of the Cost (current US$) in Forest in Austria to that in Bangladesh?
Ensure brevity in your answer.  60.14. What is the ratio of the Cost (current US$) of CO2 damage in Austria to that in Cayman Islands?
Make the answer very short. 927.06. What is the ratio of the Cost (current US$) in Minerals in Austria to that in Cayman Islands?
Provide a short and direct response. 0.32. What is the ratio of the Cost (current US$) in Energy in Austria to that in Cayman Islands?
Keep it short and to the point. 135.17. What is the ratio of the Cost (current US$) in Forest in Austria to that in Cayman Islands?
Your answer should be compact. 0. What is the ratio of the Cost (current US$) in CO2 damage in Austria to that in Cuba?
Provide a short and direct response. 2.01. What is the ratio of the Cost (current US$) in Minerals in Austria to that in Cuba?
Ensure brevity in your answer.  0.02. What is the ratio of the Cost (current US$) in Energy in Austria to that in Cuba?
Offer a terse response. 24.9. What is the ratio of the Cost (current US$) in Forest in Austria to that in Cuba?
Offer a very short reply. 33.97. What is the ratio of the Cost (current US$) in Minerals in Bangladesh to that in Cayman Islands?
Provide a succinct answer. 27.08. What is the ratio of the Cost (current US$) in Energy in Bangladesh to that in Cayman Islands?
Your answer should be very brief. 175.94. What is the ratio of the Cost (current US$) in CO2 damage in Bangladesh to that in Cuba?
Provide a succinct answer. 0.18. What is the ratio of the Cost (current US$) in Minerals in Bangladesh to that in Cuba?
Your response must be concise. 1.62. What is the ratio of the Cost (current US$) of Energy in Bangladesh to that in Cuba?
Keep it short and to the point. 32.41. What is the ratio of the Cost (current US$) of Forest in Bangladesh to that in Cuba?
Your answer should be compact. 0.56. What is the ratio of the Cost (current US$) of CO2 damage in Cayman Islands to that in Cuba?
Offer a very short reply. 0. What is the ratio of the Cost (current US$) in Minerals in Cayman Islands to that in Cuba?
Give a very brief answer. 0.06. What is the ratio of the Cost (current US$) in Energy in Cayman Islands to that in Cuba?
Offer a very short reply. 0.18. What is the ratio of the Cost (current US$) of Forest in Cayman Islands to that in Cuba?
Your answer should be compact. 1.10e+04. What is the difference between the highest and the second highest Cost (current US$) in CO2 damage?
Provide a succinct answer. 7.90e+07. What is the difference between the highest and the second highest Cost (current US$) of Minerals?
Keep it short and to the point. 2.86e+08. What is the difference between the highest and the second highest Cost (current US$) in Energy?
Your answer should be very brief. 1.07e+09. What is the difference between the highest and the second highest Cost (current US$) in Forest?
Keep it short and to the point. 1.20e+09. What is the difference between the highest and the lowest Cost (current US$) in CO2 damage?
Make the answer very short. 1.85e+08. What is the difference between the highest and the lowest Cost (current US$) of Minerals?
Offer a very short reply. 7.40e+08. What is the difference between the highest and the lowest Cost (current US$) in Energy?
Offer a very short reply. 2.59e+09. What is the difference between the highest and the lowest Cost (current US$) of Forest?
Your answer should be very brief. 1.66e+09. 